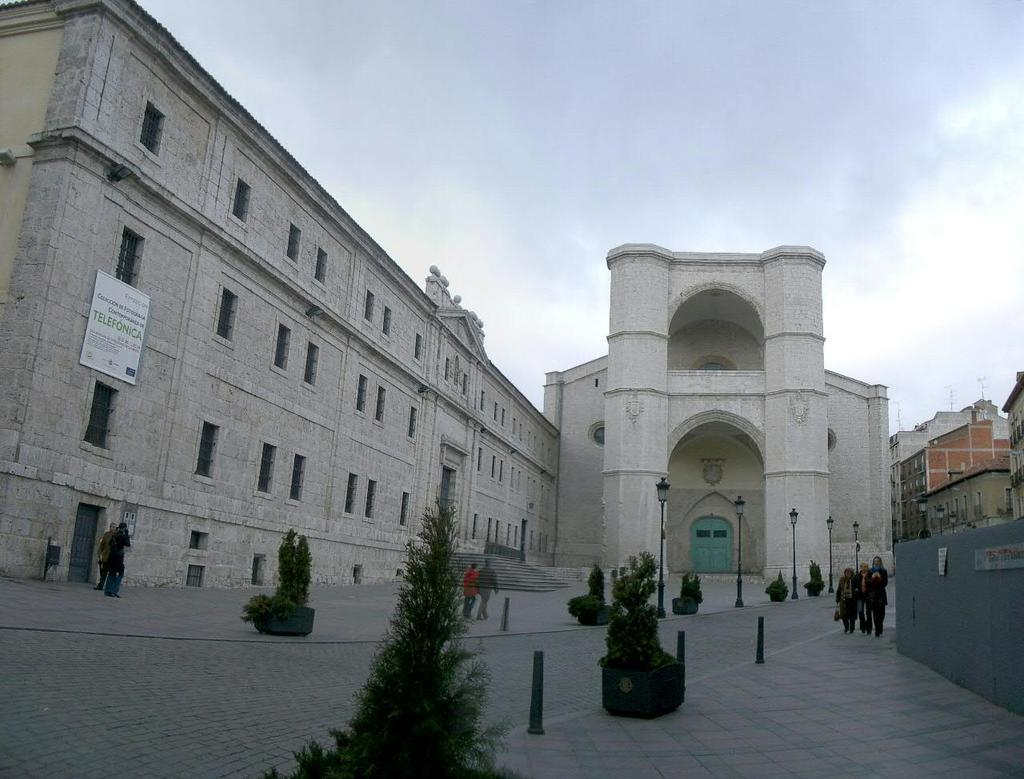Who or what can be seen in the image? There are people in the image. What else is present in the image besides people? There are plants, a wall, lights on poles, buildings in the background, and the sky visible in the background. Can you describe the board that is present in the image? There is a board on one of the buildings in the image. What type of dinosaur can be seen attacking the buildings in the image? There are no dinosaurs present in the image, and therefore no such attack can be observed. 